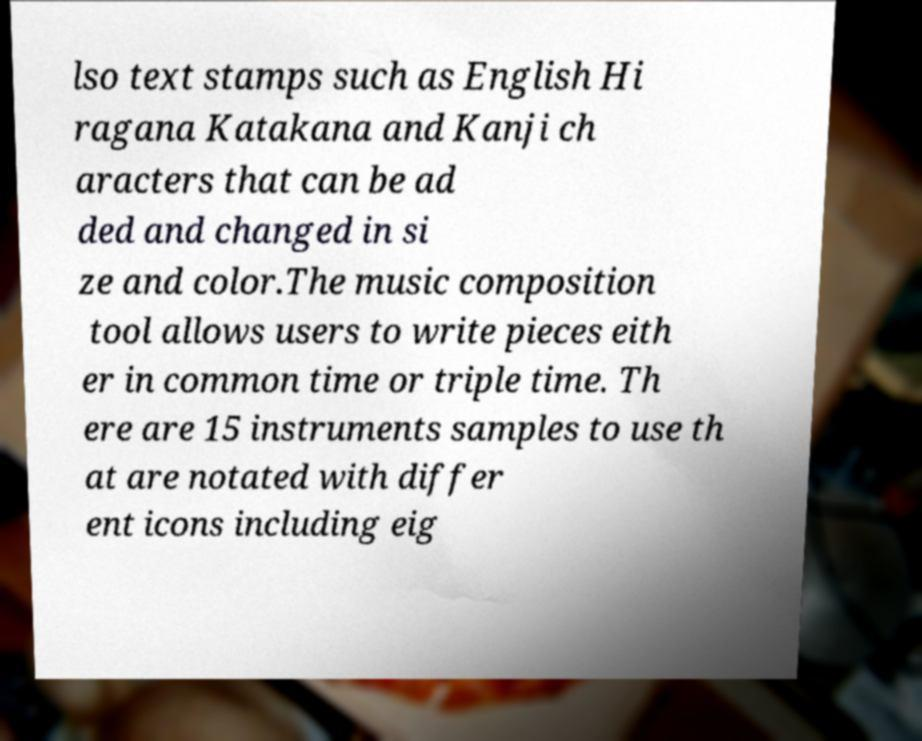Could you assist in decoding the text presented in this image and type it out clearly? lso text stamps such as English Hi ragana Katakana and Kanji ch aracters that can be ad ded and changed in si ze and color.The music composition tool allows users to write pieces eith er in common time or triple time. Th ere are 15 instruments samples to use th at are notated with differ ent icons including eig 